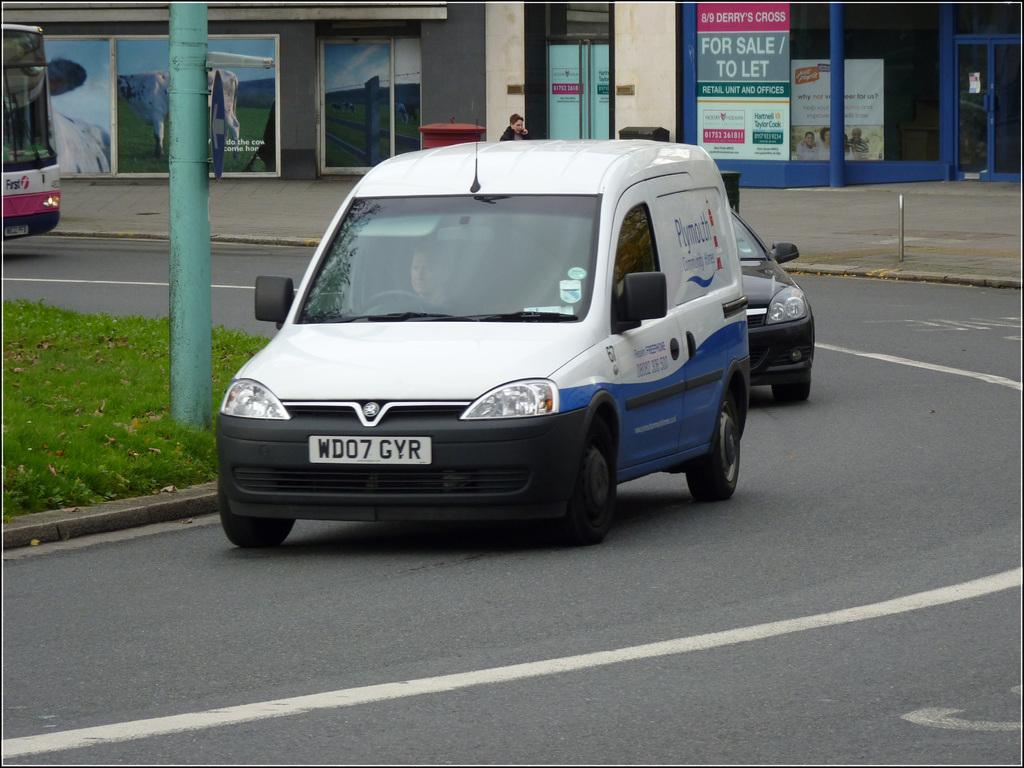What is happening on the road in the image? There are vehicles on the road in the image. What type of vegetation can be seen in the image? Grass is visible in the image. What structure can be seen in the image? There is a pole in the image. What type of barrier is present in the image? A fence is present in the image. What type of structures are visible in the image? There are buildings in the image. What architectural elements can be seen in the image? Pillars are visible in the image. What type of signage is present in the image? Posters and boards are visible in the image. What type of access points are present in the image? Doors are present in the image. Where was the image taken? The image appears to be taken on the road. How many feet are visible in the image? There are no feet visible in the image. What type of test is being conducted in the image? There is no test being conducted in the image. What type of furniture is present in the image? There is no table or any other furniture present in the image. 